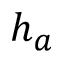<formula> <loc_0><loc_0><loc_500><loc_500>h _ { a }</formula> 